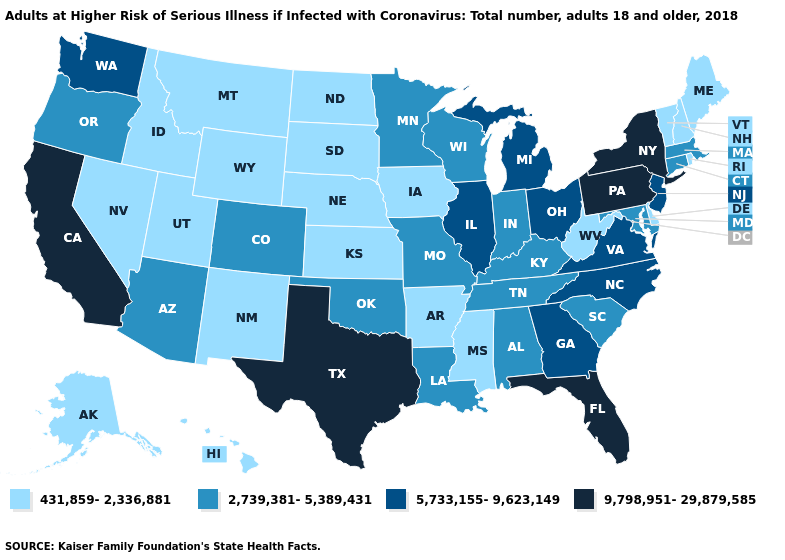What is the value of Connecticut?
Answer briefly. 2,739,381-5,389,431. Does Florida have the highest value in the USA?
Be succinct. Yes. What is the value of Rhode Island?
Quick response, please. 431,859-2,336,881. What is the value of West Virginia?
Be succinct. 431,859-2,336,881. Which states have the lowest value in the USA?
Write a very short answer. Alaska, Arkansas, Delaware, Hawaii, Idaho, Iowa, Kansas, Maine, Mississippi, Montana, Nebraska, Nevada, New Hampshire, New Mexico, North Dakota, Rhode Island, South Dakota, Utah, Vermont, West Virginia, Wyoming. What is the value of Delaware?
Be succinct. 431,859-2,336,881. Among the states that border New Jersey , which have the highest value?
Short answer required. New York, Pennsylvania. What is the highest value in states that border North Carolina?
Write a very short answer. 5,733,155-9,623,149. Among the states that border Iowa , does Missouri have the lowest value?
Give a very brief answer. No. Name the states that have a value in the range 5,733,155-9,623,149?
Write a very short answer. Georgia, Illinois, Michigan, New Jersey, North Carolina, Ohio, Virginia, Washington. Name the states that have a value in the range 2,739,381-5,389,431?
Give a very brief answer. Alabama, Arizona, Colorado, Connecticut, Indiana, Kentucky, Louisiana, Maryland, Massachusetts, Minnesota, Missouri, Oklahoma, Oregon, South Carolina, Tennessee, Wisconsin. What is the highest value in the South ?
Be succinct. 9,798,951-29,879,585. Does Connecticut have the lowest value in the Northeast?
Answer briefly. No. Name the states that have a value in the range 2,739,381-5,389,431?
Be succinct. Alabama, Arizona, Colorado, Connecticut, Indiana, Kentucky, Louisiana, Maryland, Massachusetts, Minnesota, Missouri, Oklahoma, Oregon, South Carolina, Tennessee, Wisconsin. Does the first symbol in the legend represent the smallest category?
Be succinct. Yes. 